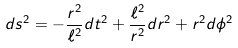<formula> <loc_0><loc_0><loc_500><loc_500>d s ^ { 2 } = - \frac { r ^ { 2 } } { \ell ^ { 2 } } d t ^ { 2 } + \frac { \ell ^ { 2 } } { r ^ { 2 } } d r ^ { 2 } + r ^ { 2 } d \phi ^ { 2 }</formula> 